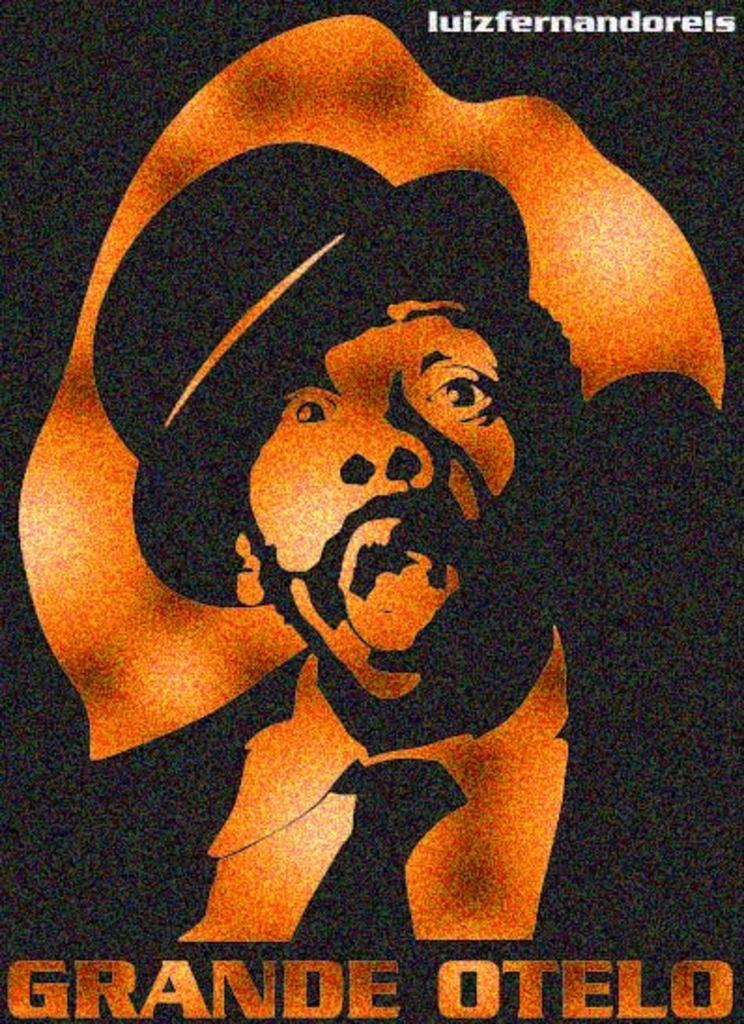<image>
Offer a succinct explanation of the picture presented. A two toned picture of a man in a suit and hat is entitled Grande Otelo. 